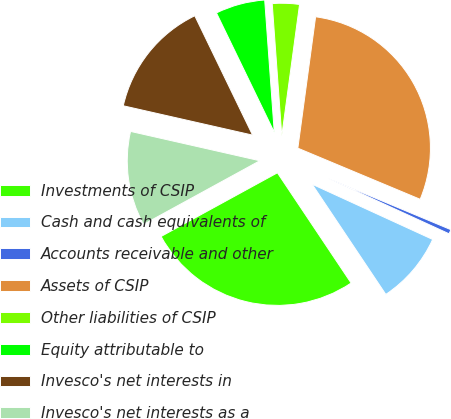Convert chart to OTSL. <chart><loc_0><loc_0><loc_500><loc_500><pie_chart><fcel>Investments of CSIP<fcel>Cash and cash equivalents of<fcel>Accounts receivable and other<fcel>Assets of CSIP<fcel>Other liabilities of CSIP<fcel>Equity attributable to<fcel>Invesco's net interests in<fcel>Invesco's net interests as a<nl><fcel>26.41%<fcel>8.78%<fcel>0.54%<fcel>29.16%<fcel>3.29%<fcel>6.03%<fcel>14.27%<fcel>11.52%<nl></chart> 